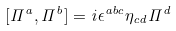<formula> <loc_0><loc_0><loc_500><loc_500>[ \Pi ^ { a } , \Pi ^ { b } ] = i \epsilon ^ { a b c } \eta _ { c d } \Pi ^ { d }</formula> 